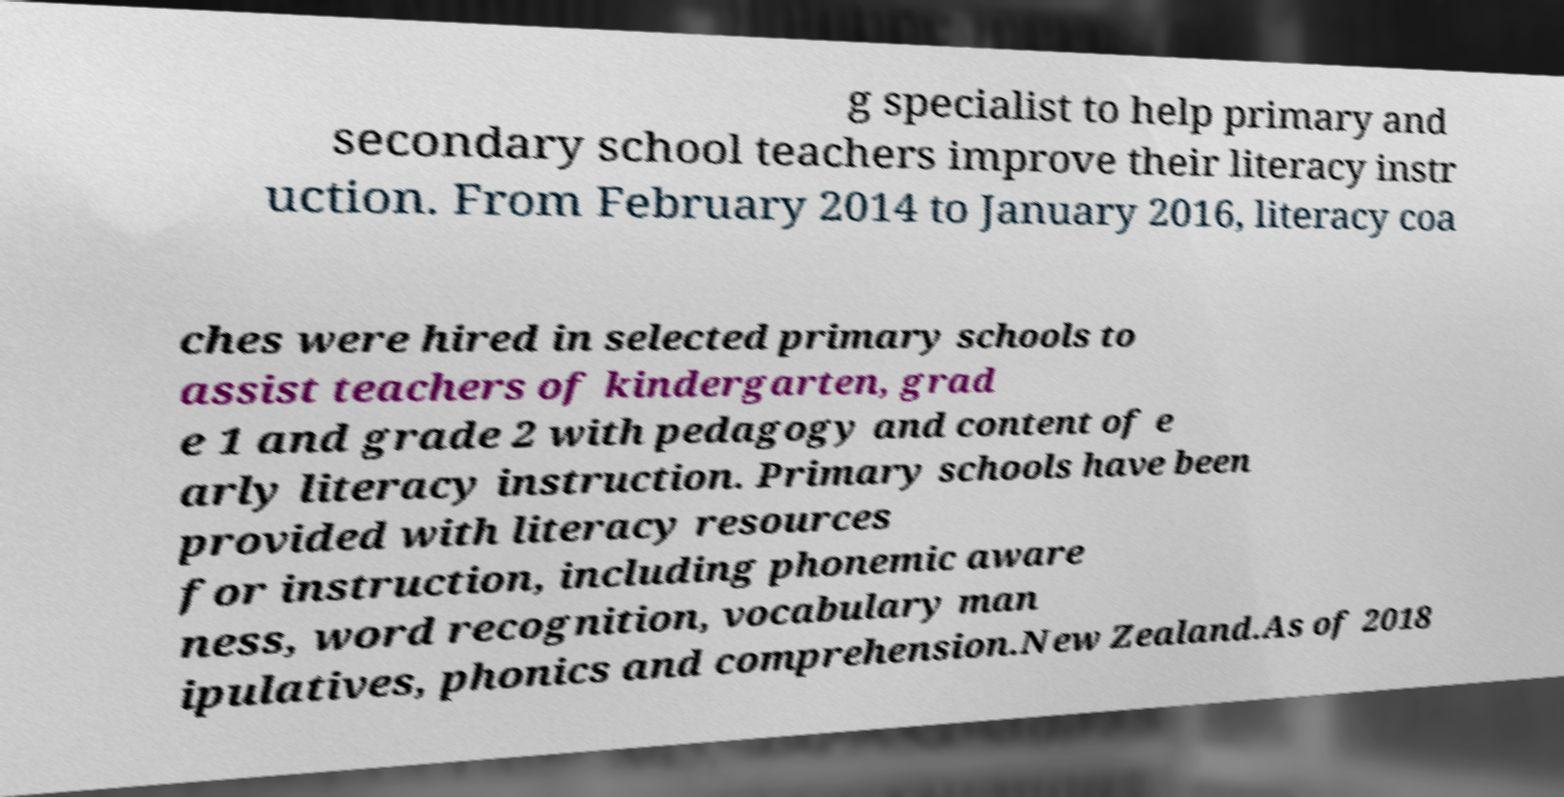Could you extract and type out the text from this image? g specialist to help primary and secondary school teachers improve their literacy instr uction. From February 2014 to January 2016, literacy coa ches were hired in selected primary schools to assist teachers of kindergarten, grad e 1 and grade 2 with pedagogy and content of e arly literacy instruction. Primary schools have been provided with literacy resources for instruction, including phonemic aware ness, word recognition, vocabulary man ipulatives, phonics and comprehension.New Zealand.As of 2018 